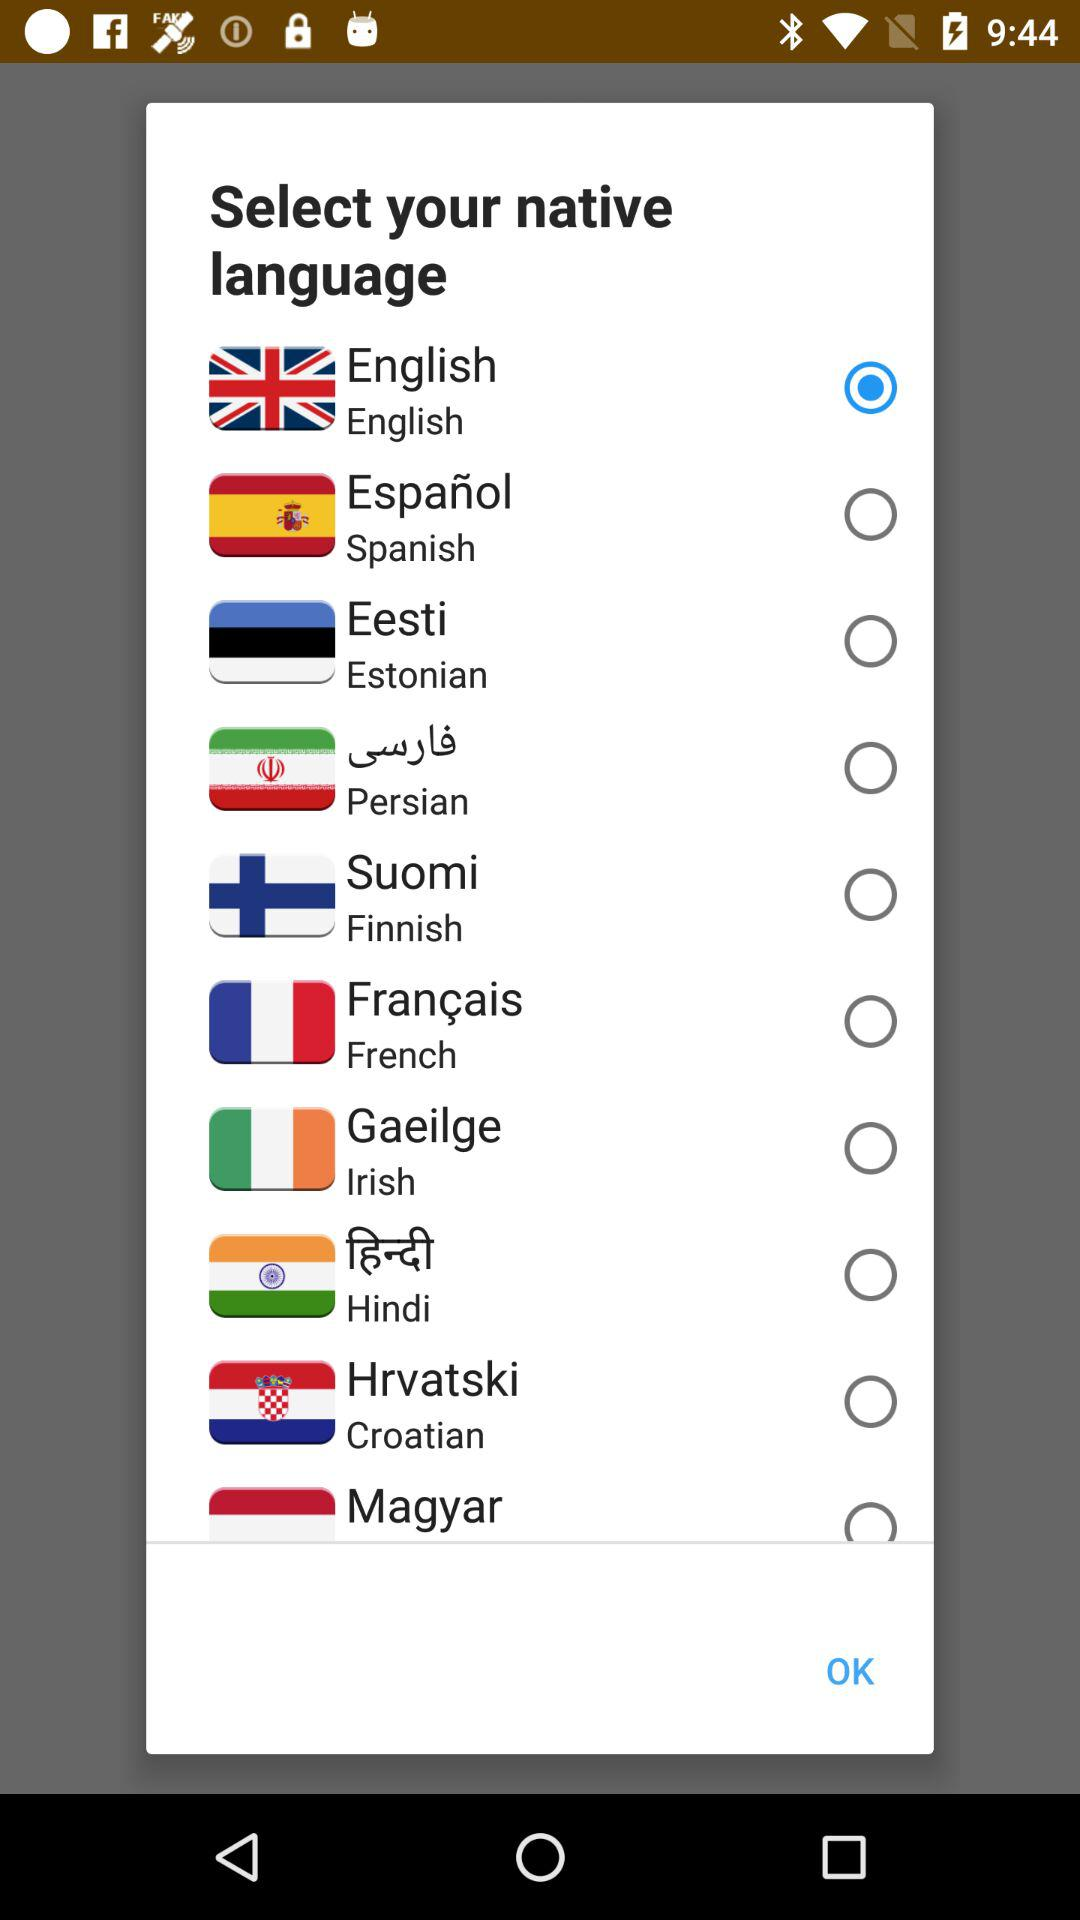Which language has been selected? The selected language is English. 